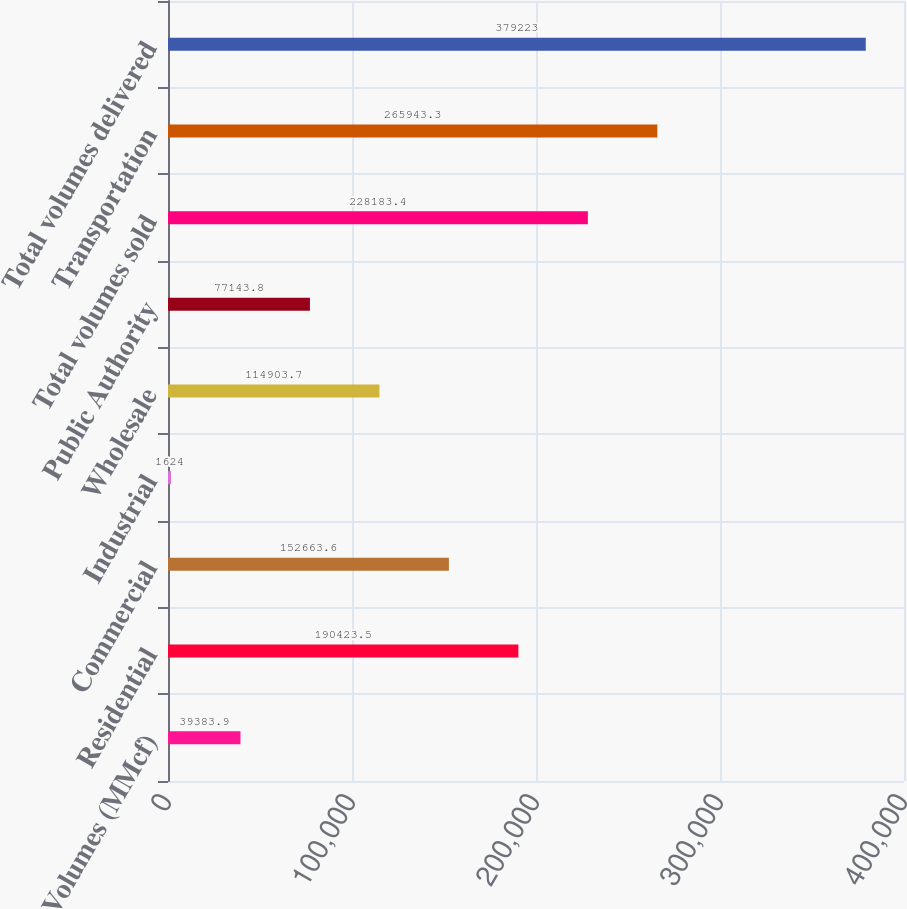<chart> <loc_0><loc_0><loc_500><loc_500><bar_chart><fcel>Volumes (MMcf)<fcel>Residential<fcel>Commercial<fcel>Industrial<fcel>Wholesale<fcel>Public Authority<fcel>Total volumes sold<fcel>Transportation<fcel>Total volumes delivered<nl><fcel>39383.9<fcel>190424<fcel>152664<fcel>1624<fcel>114904<fcel>77143.8<fcel>228183<fcel>265943<fcel>379223<nl></chart> 